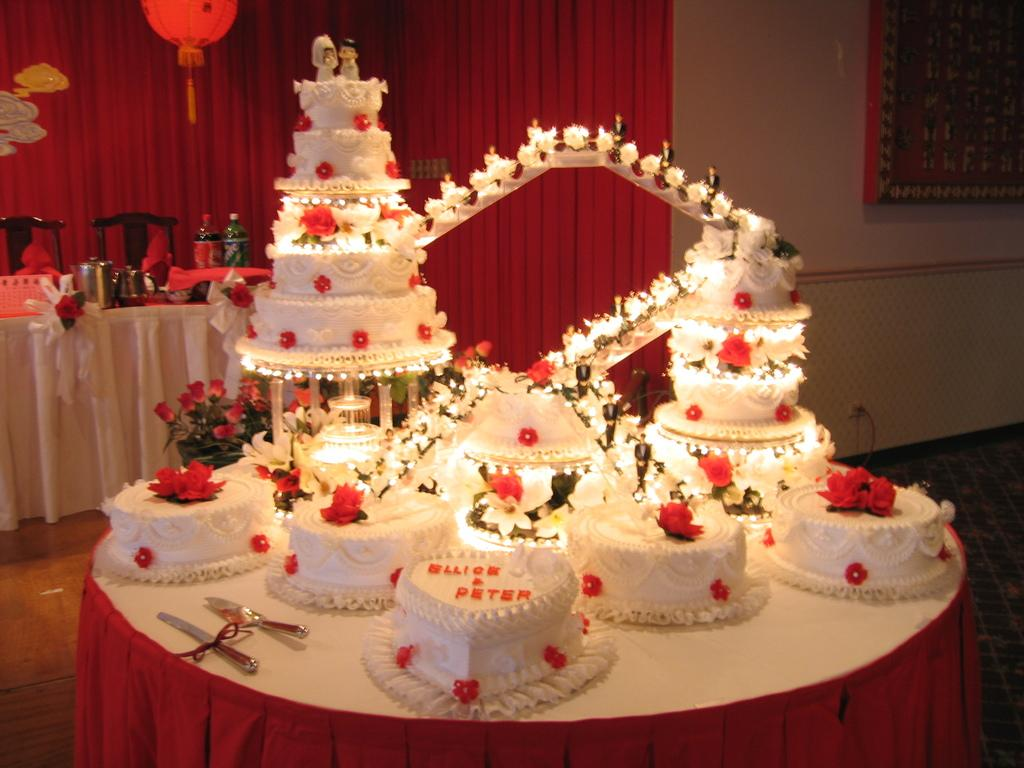What type of food can be seen on the table in the image? There are cakes arranged on a table in the image. Can you describe the object present in the image? Unfortunately, the provided facts do not give any information about the object present in the image. What decision did the cake make in the image? Cakes do not make decisions, as they are inanimate objects. 